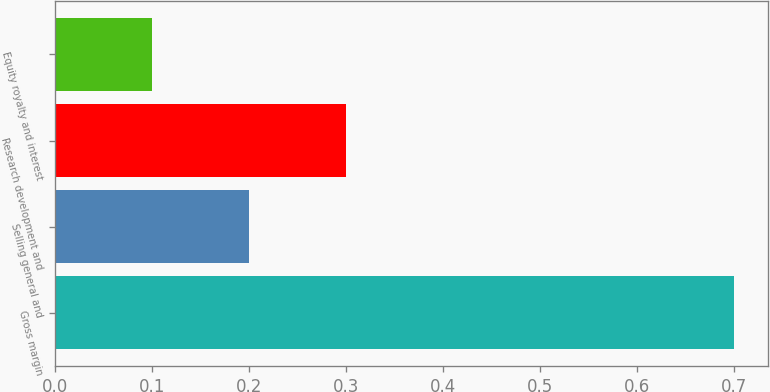Convert chart. <chart><loc_0><loc_0><loc_500><loc_500><bar_chart><fcel>Gross margin<fcel>Selling general and<fcel>Research development and<fcel>Equity royalty and interest<nl><fcel>0.7<fcel>0.2<fcel>0.3<fcel>0.1<nl></chart> 